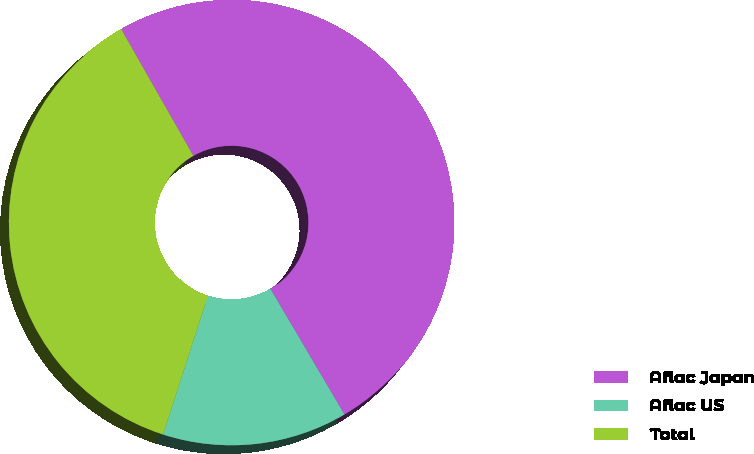Convert chart. <chart><loc_0><loc_0><loc_500><loc_500><pie_chart><fcel>Aflac Japan<fcel>Aflac US<fcel>Total<nl><fcel>49.77%<fcel>13.45%<fcel>36.79%<nl></chart> 